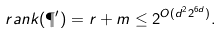<formula> <loc_0><loc_0><loc_500><loc_500>\ r a n k ( \P ^ { \prime } ) = r + m \leq 2 ^ { O ( d ^ { 2 } 2 ^ { 6 d } ) } .</formula> 